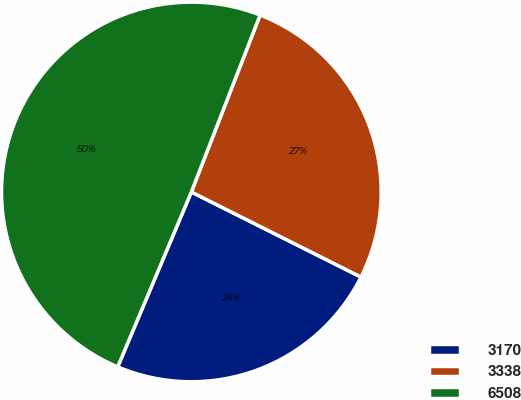Convert chart. <chart><loc_0><loc_0><loc_500><loc_500><pie_chart><fcel>3170<fcel>3338<fcel>6508<nl><fcel>23.94%<fcel>26.5%<fcel>49.55%<nl></chart> 